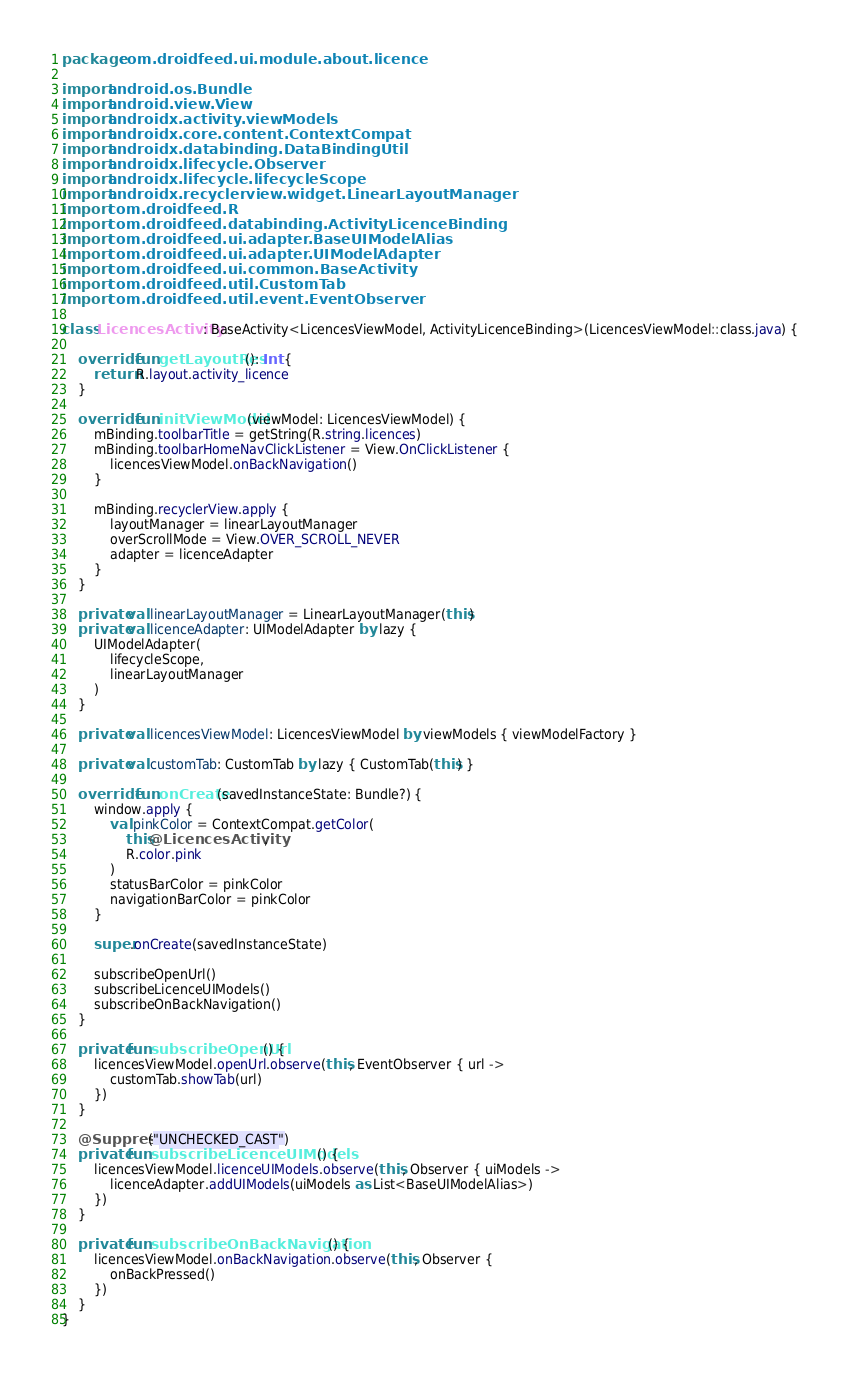Convert code to text. <code><loc_0><loc_0><loc_500><loc_500><_Kotlin_>package com.droidfeed.ui.module.about.licence

import android.os.Bundle
import android.view.View
import androidx.activity.viewModels
import androidx.core.content.ContextCompat
import androidx.databinding.DataBindingUtil
import androidx.lifecycle.Observer
import androidx.lifecycle.lifecycleScope
import androidx.recyclerview.widget.LinearLayoutManager
import com.droidfeed.R
import com.droidfeed.databinding.ActivityLicenceBinding
import com.droidfeed.ui.adapter.BaseUIModelAlias
import com.droidfeed.ui.adapter.UIModelAdapter
import com.droidfeed.ui.common.BaseActivity
import com.droidfeed.util.CustomTab
import com.droidfeed.util.event.EventObserver

class LicencesActivity : BaseActivity<LicencesViewModel, ActivityLicenceBinding>(LicencesViewModel::class.java) {

    override fun getLayoutRes(): Int {
        return R.layout.activity_licence
    }

    override fun initViewModel(viewModel: LicencesViewModel) {
        mBinding.toolbarTitle = getString(R.string.licences)
        mBinding.toolbarHomeNavClickListener = View.OnClickListener {
            licencesViewModel.onBackNavigation()
        }

        mBinding.recyclerView.apply {
            layoutManager = linearLayoutManager
            overScrollMode = View.OVER_SCROLL_NEVER
            adapter = licenceAdapter
        }
    }

    private val linearLayoutManager = LinearLayoutManager(this)
    private val licenceAdapter: UIModelAdapter by lazy {
        UIModelAdapter(
            lifecycleScope,
            linearLayoutManager
        )
    }

    private val licencesViewModel: LicencesViewModel by viewModels { viewModelFactory }

    private val customTab: CustomTab by lazy { CustomTab(this) }

    override fun onCreate(savedInstanceState: Bundle?) {
        window.apply {
            val pinkColor = ContextCompat.getColor(
                this@LicencesActivity,
                R.color.pink
            )
            statusBarColor = pinkColor
            navigationBarColor = pinkColor
        }

        super.onCreate(savedInstanceState)

        subscribeOpenUrl()
        subscribeLicenceUIModels()
        subscribeOnBackNavigation()
    }

    private fun subscribeOpenUrl() {
        licencesViewModel.openUrl.observe(this, EventObserver { url ->
            customTab.showTab(url)
        })
    }

    @Suppress("UNCHECKED_CAST")
    private fun subscribeLicenceUIModels() {
        licencesViewModel.licenceUIModels.observe(this, Observer { uiModels ->
            licenceAdapter.addUIModels(uiModels as List<BaseUIModelAlias>)
        })
    }

    private fun subscribeOnBackNavigation() {
        licencesViewModel.onBackNavigation.observe(this, Observer {
            onBackPressed()
        })
    }
}</code> 